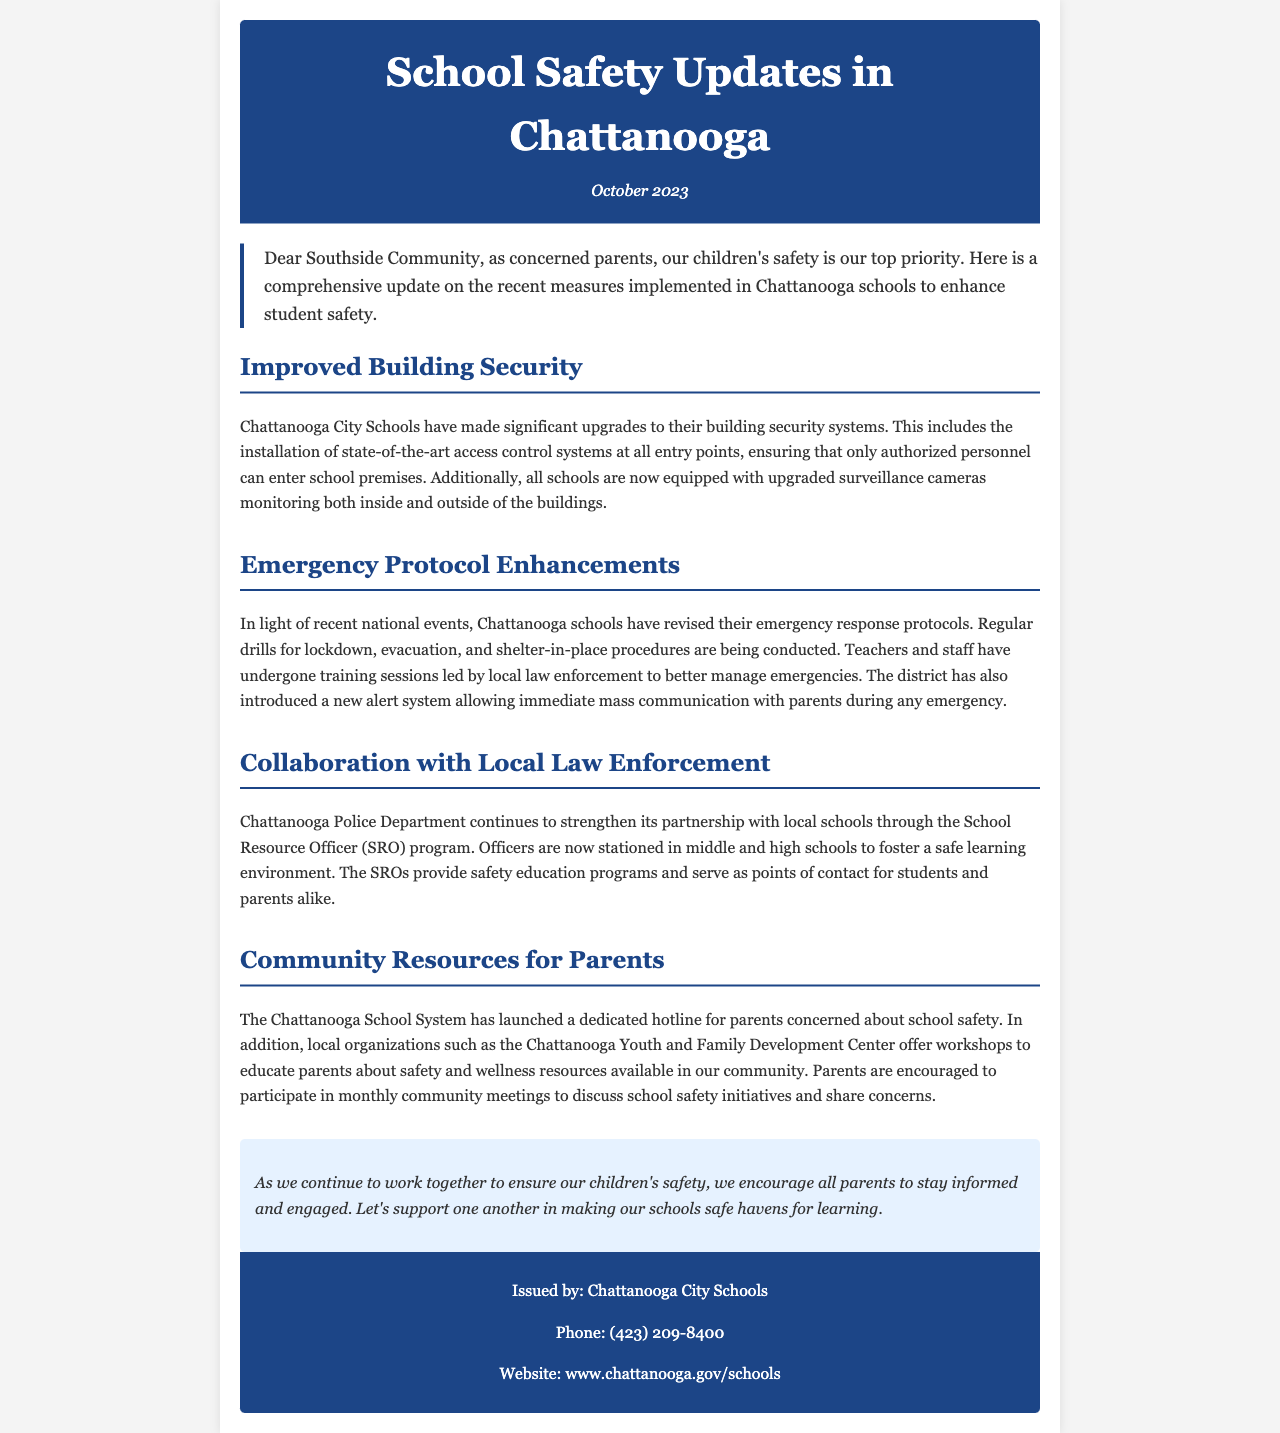What recent upgrades have been made to school security? The document mentions the installation of state-of-the-art access control systems at all entry points and upgraded surveillance cameras.
Answer: access control systems and upgraded surveillance cameras What is the purpose of the School Resource Officer (SRO) program? The SRO program aims to foster a safe learning environment and provide safety education programs.
Answer: foster a safe learning environment What new system has been introduced for emergency communication with parents? The district has introduced a new alert system allowing immediate mass communication with parents during any emergency.
Answer: new alert system How are teachers and staff being prepared for emergencies? They have undergone training sessions led by local law enforcement to better manage emergencies.
Answer: training sessions What hotline has been launched for parents? A dedicated hotline for parents concerned about school safety has been launched by the Chattanooga School System.
Answer: dedicated hotline What type of meetings are parents encouraged to participate in regarding school safety? Parents are encouraged to participate in monthly community meetings to discuss school safety initiatives.
Answer: monthly community meetings What month and year is the newsletter published? The newsletter is published in October 2023.
Answer: October 2023 How can parents access information about school safety resources in the community? Parents can access workshops offered by local organizations such as the Chattanooga Youth and Family Development Center.
Answer: workshops What is the address of the Chattanooga City Schools website? The website for Chattanooga City Schools is provided in the footer of the newsletter.
Answer: www.chattanooga.gov/schools 